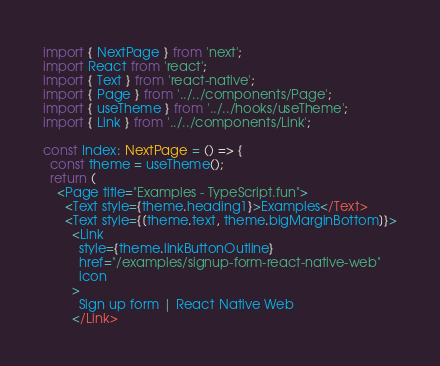Convert code to text. <code><loc_0><loc_0><loc_500><loc_500><_TypeScript_>import { NextPage } from 'next';
import React from 'react';
import { Text } from 'react-native';
import { Page } from '../../components/Page';
import { useTheme } from '../../hooks/useTheme';
import { Link } from '../../components/Link';

const Index: NextPage = () => {
  const theme = useTheme();
  return (
    <Page title="Examples - TypeScript.fun">
      <Text style={theme.heading1}>Examples</Text>
      <Text style={[theme.text, theme.bigMarginBottom]}>
        <Link
          style={theme.linkButtonOutline}
          href="/examples/signup-form-react-native-web"
          icon
        >
          Sign up form | React Native Web
        </Link></code> 